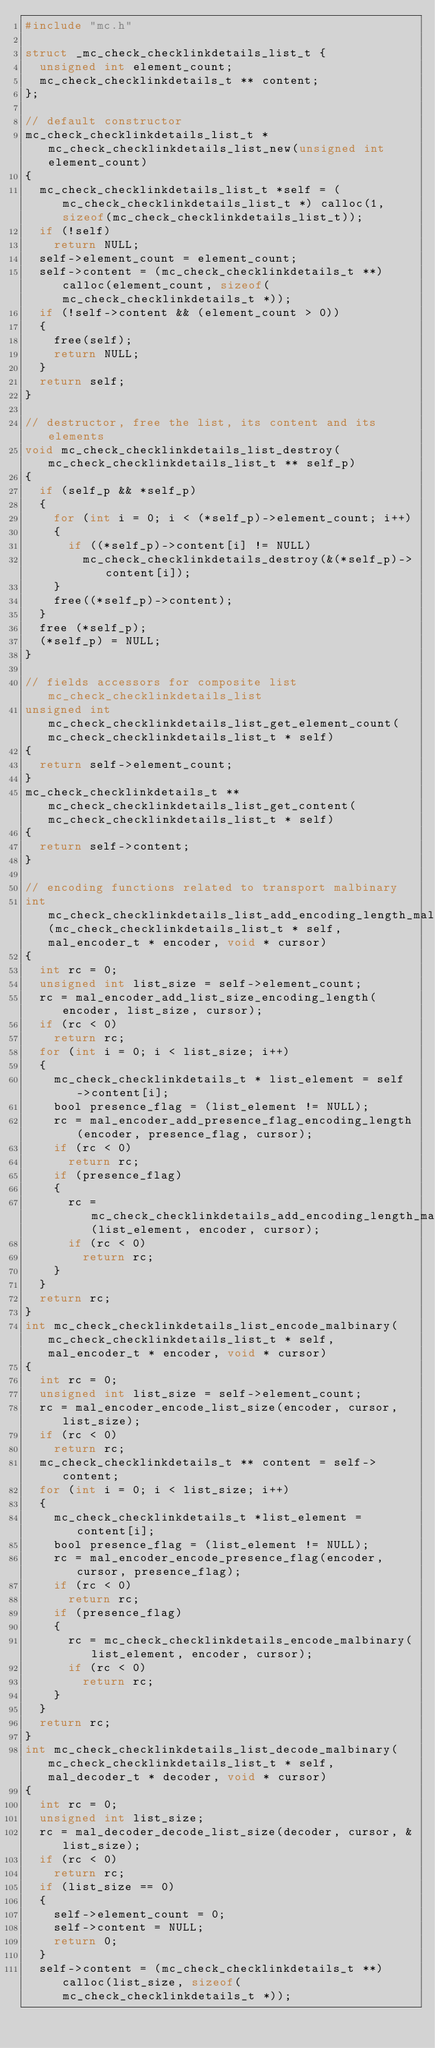<code> <loc_0><loc_0><loc_500><loc_500><_C_>#include "mc.h"

struct _mc_check_checklinkdetails_list_t {
  unsigned int element_count;
  mc_check_checklinkdetails_t ** content;
};

// default constructor
mc_check_checklinkdetails_list_t * mc_check_checklinkdetails_list_new(unsigned int element_count)
{
  mc_check_checklinkdetails_list_t *self = (mc_check_checklinkdetails_list_t *) calloc(1, sizeof(mc_check_checklinkdetails_list_t));
  if (!self)
    return NULL;
  self->element_count = element_count;
  self->content = (mc_check_checklinkdetails_t **) calloc(element_count, sizeof(mc_check_checklinkdetails_t *));
  if (!self->content && (element_count > 0))
  {
    free(self);
    return NULL;
  }
  return self;
}

// destructor, free the list, its content and its elements
void mc_check_checklinkdetails_list_destroy(mc_check_checklinkdetails_list_t ** self_p)
{
  if (self_p && *self_p)
  {
    for (int i = 0; i < (*self_p)->element_count; i++)
    {
      if ((*self_p)->content[i] != NULL)
        mc_check_checklinkdetails_destroy(&(*self_p)->content[i]);
    }
    free((*self_p)->content);
  }
  free (*self_p);
  (*self_p) = NULL;
}

// fields accessors for composite list mc_check_checklinkdetails_list
unsigned int mc_check_checklinkdetails_list_get_element_count(mc_check_checklinkdetails_list_t * self)
{
  return self->element_count;
}
mc_check_checklinkdetails_t ** mc_check_checklinkdetails_list_get_content(mc_check_checklinkdetails_list_t * self)
{
  return self->content;
}

// encoding functions related to transport malbinary
int mc_check_checklinkdetails_list_add_encoding_length_malbinary(mc_check_checklinkdetails_list_t * self, mal_encoder_t * encoder, void * cursor)
{
  int rc = 0;
  unsigned int list_size = self->element_count;
  rc = mal_encoder_add_list_size_encoding_length(encoder, list_size, cursor);
  if (rc < 0)
    return rc;
  for (int i = 0; i < list_size; i++)
  {
    mc_check_checklinkdetails_t * list_element = self->content[i];
    bool presence_flag = (list_element != NULL);
    rc = mal_encoder_add_presence_flag_encoding_length(encoder, presence_flag, cursor);
    if (rc < 0)
      return rc;
    if (presence_flag)
    {
      rc = mc_check_checklinkdetails_add_encoding_length_malbinary(list_element, encoder, cursor);
      if (rc < 0)
        return rc;
    }
  }
  return rc;
}
int mc_check_checklinkdetails_list_encode_malbinary(mc_check_checklinkdetails_list_t * self, mal_encoder_t * encoder, void * cursor)
{
  int rc = 0;
  unsigned int list_size = self->element_count;
  rc = mal_encoder_encode_list_size(encoder, cursor, list_size);
  if (rc < 0)
    return rc;
  mc_check_checklinkdetails_t ** content = self->content;
  for (int i = 0; i < list_size; i++)
  {
    mc_check_checklinkdetails_t *list_element = content[i];
    bool presence_flag = (list_element != NULL);
    rc = mal_encoder_encode_presence_flag(encoder, cursor, presence_flag);
    if (rc < 0)
      return rc;
    if (presence_flag)
    {
      rc = mc_check_checklinkdetails_encode_malbinary(list_element, encoder, cursor);
      if (rc < 0)
        return rc;
    }
  }
  return rc;
}
int mc_check_checklinkdetails_list_decode_malbinary(mc_check_checklinkdetails_list_t * self, mal_decoder_t * decoder, void * cursor)
{
  int rc = 0;
  unsigned int list_size;
  rc = mal_decoder_decode_list_size(decoder, cursor, &list_size);
  if (rc < 0)
    return rc;
  if (list_size == 0)
  {
    self->element_count = 0;
    self->content = NULL;
    return 0;
  }
  self->content = (mc_check_checklinkdetails_t **) calloc(list_size, sizeof(mc_check_checklinkdetails_t *));</code> 